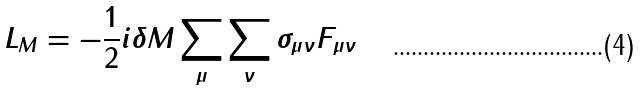Convert formula to latex. <formula><loc_0><loc_0><loc_500><loc_500>L _ { M } = - \frac { 1 } { 2 } i \delta M \sum _ { \mu } \sum _ { \nu } \sigma _ { \mu \nu } F _ { \mu \nu }</formula> 